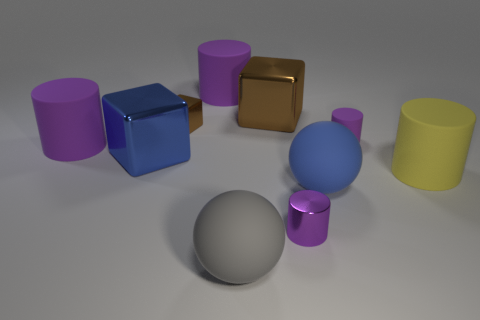What materials do the objects in the image appear to be made of? The objects in this image seem to be rendered with different types of materials. The cylinder and sphere in the foreground have metallic finishes, suggesting they are made of metal. The other objects have a matte finish, possibly indicating plastic or a painted surface. Do the objects cast any shadows that suggest a light source? Yes, each object casts a shadow on the surface beneath it. The direction and length of the shadows suggest that the light source is above and to the left of the scene. 